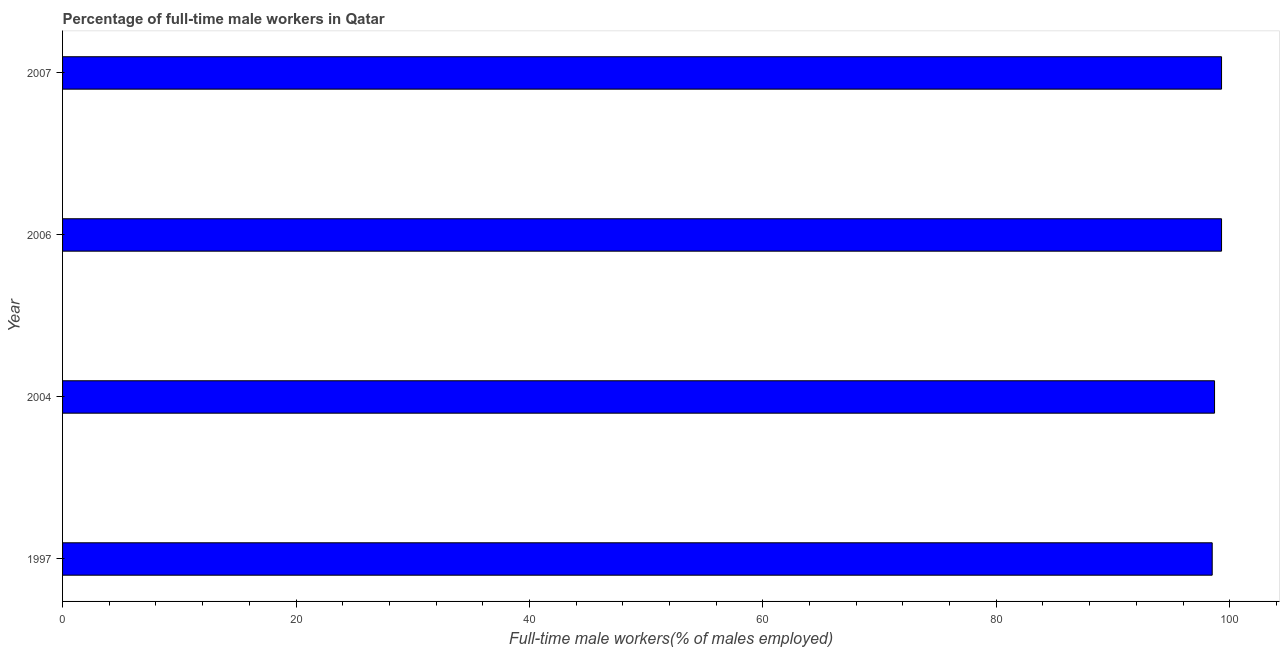Does the graph contain any zero values?
Your response must be concise. No. What is the title of the graph?
Your answer should be compact. Percentage of full-time male workers in Qatar. What is the label or title of the X-axis?
Offer a very short reply. Full-time male workers(% of males employed). What is the label or title of the Y-axis?
Provide a short and direct response. Year. What is the percentage of full-time male workers in 2006?
Make the answer very short. 99.3. Across all years, what is the maximum percentage of full-time male workers?
Keep it short and to the point. 99.3. Across all years, what is the minimum percentage of full-time male workers?
Keep it short and to the point. 98.5. In which year was the percentage of full-time male workers maximum?
Your answer should be very brief. 2006. In which year was the percentage of full-time male workers minimum?
Your answer should be compact. 1997. What is the sum of the percentage of full-time male workers?
Your answer should be very brief. 395.8. What is the average percentage of full-time male workers per year?
Make the answer very short. 98.95. What is the median percentage of full-time male workers?
Keep it short and to the point. 99. Do a majority of the years between 2006 and 1997 (inclusive) have percentage of full-time male workers greater than 56 %?
Your response must be concise. Yes. Is the percentage of full-time male workers in 1997 less than that in 2006?
Offer a terse response. Yes. How many bars are there?
Your answer should be compact. 4. Are all the bars in the graph horizontal?
Your response must be concise. Yes. How many years are there in the graph?
Provide a short and direct response. 4. What is the difference between two consecutive major ticks on the X-axis?
Offer a very short reply. 20. What is the Full-time male workers(% of males employed) in 1997?
Ensure brevity in your answer.  98.5. What is the Full-time male workers(% of males employed) of 2004?
Make the answer very short. 98.7. What is the Full-time male workers(% of males employed) of 2006?
Make the answer very short. 99.3. What is the Full-time male workers(% of males employed) of 2007?
Your answer should be compact. 99.3. What is the difference between the Full-time male workers(% of males employed) in 1997 and 2004?
Provide a short and direct response. -0.2. What is the difference between the Full-time male workers(% of males employed) in 2004 and 2006?
Give a very brief answer. -0.6. What is the difference between the Full-time male workers(% of males employed) in 2004 and 2007?
Keep it short and to the point. -0.6. What is the ratio of the Full-time male workers(% of males employed) in 1997 to that in 2004?
Provide a short and direct response. 1. What is the ratio of the Full-time male workers(% of males employed) in 1997 to that in 2006?
Give a very brief answer. 0.99. 